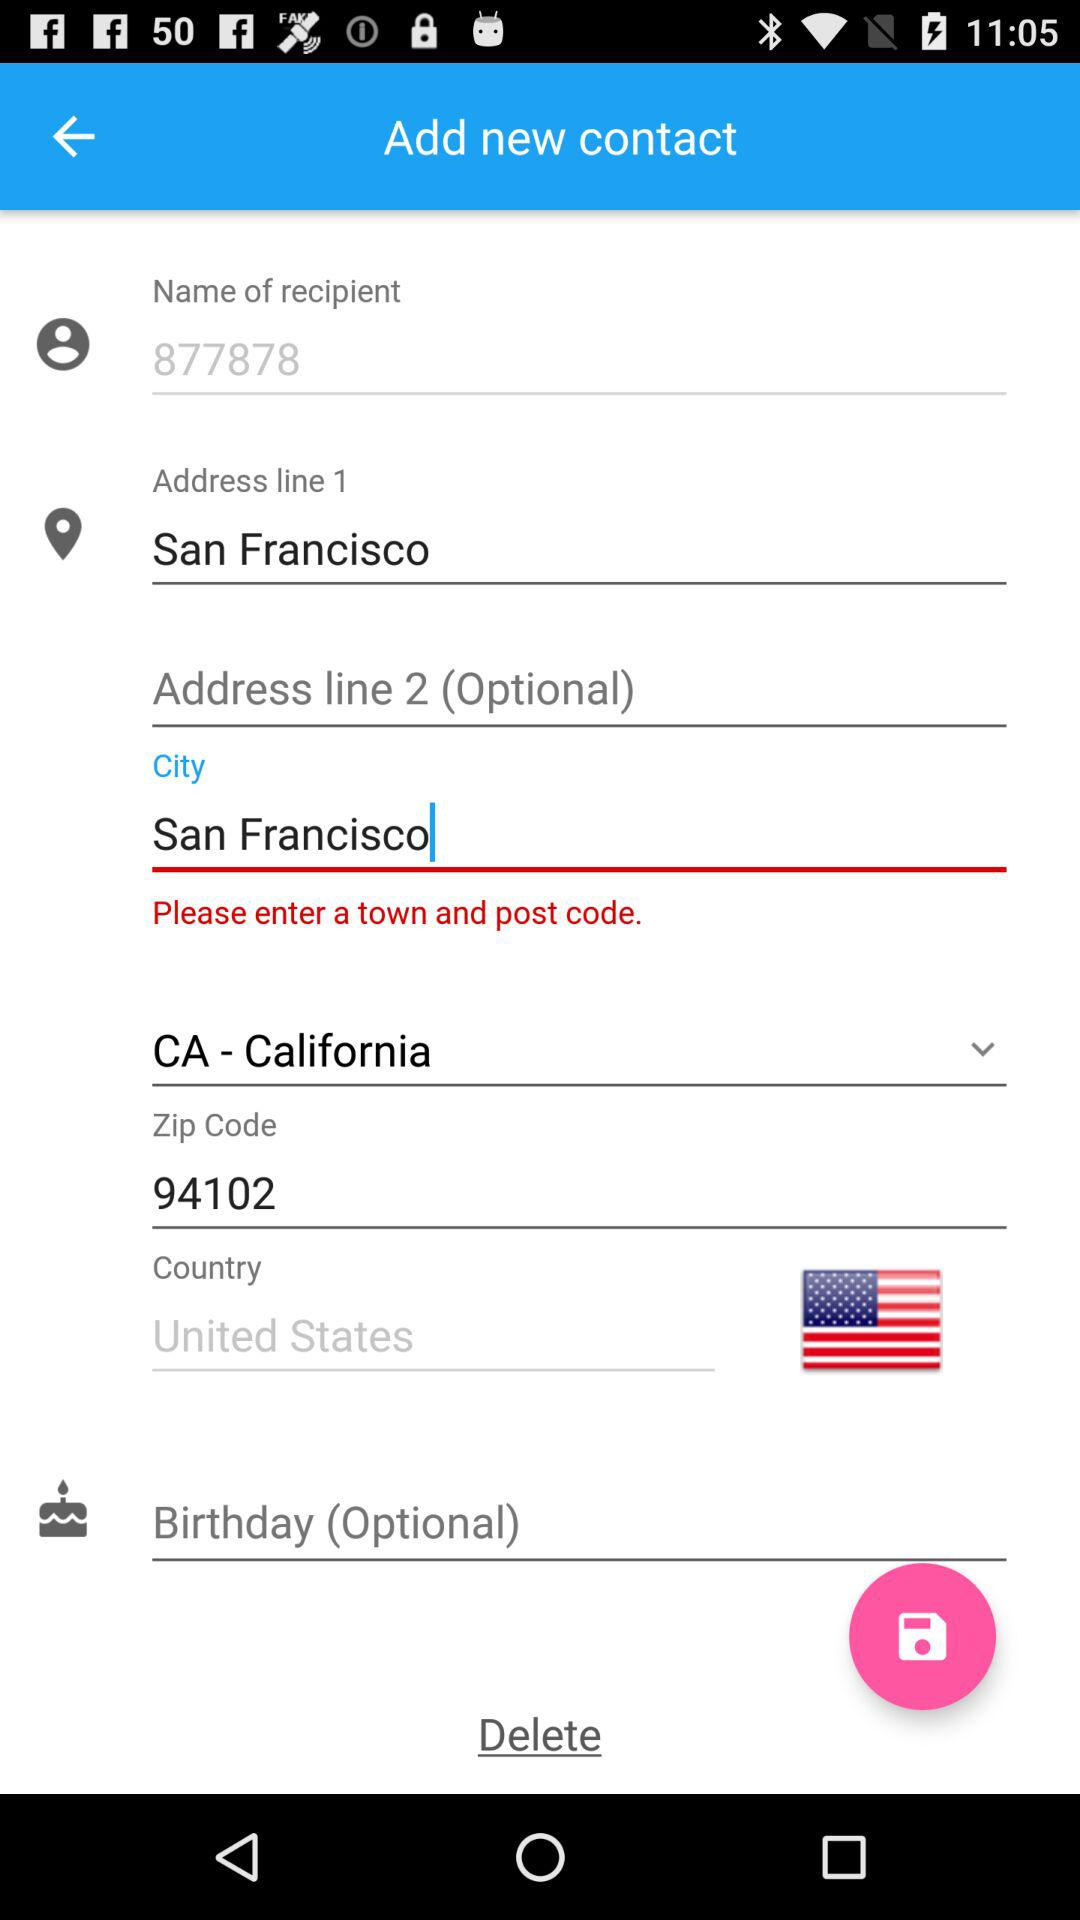What city's zip code is 94102? The city is San Francisco. 